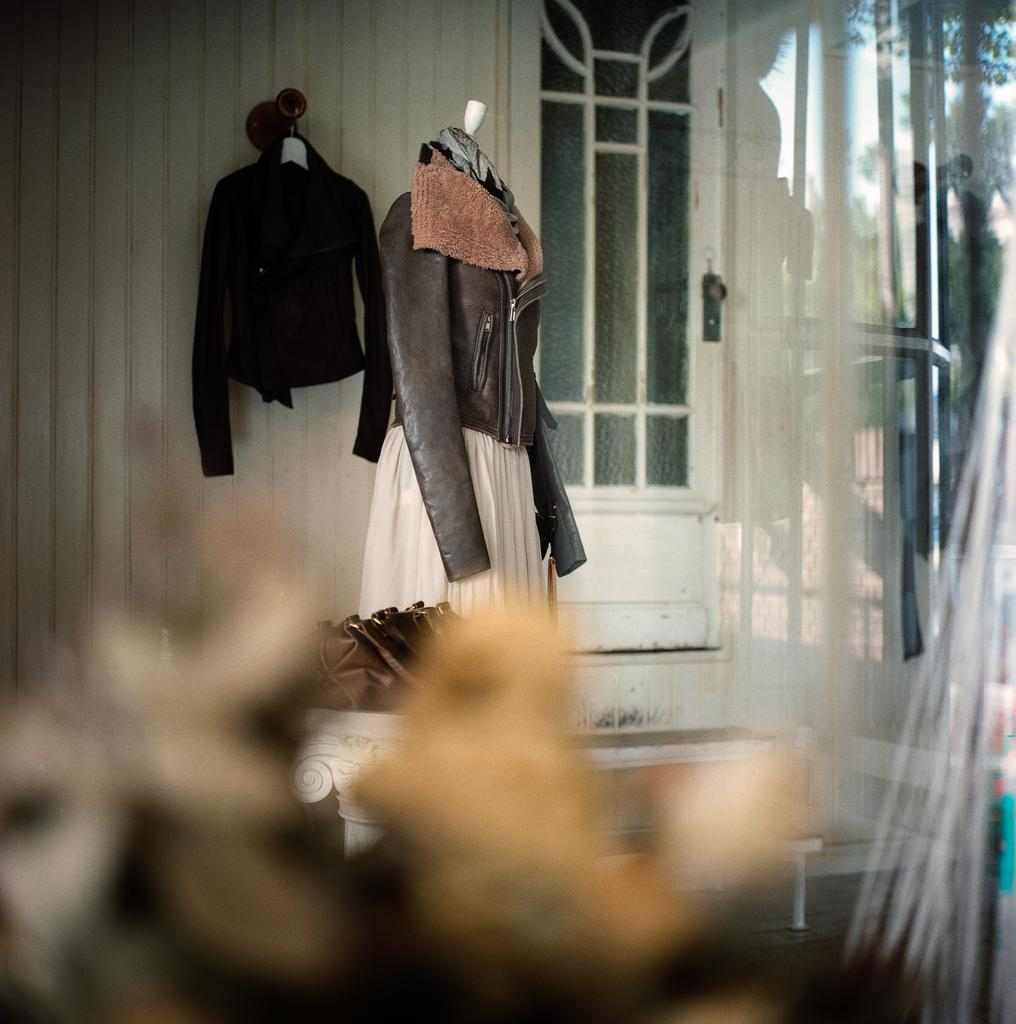What is the main subject of the image? The main subject of the image is an outfit displayed. Are there any other objects or animals in the image? Yes, there is a cat hanging on the wall and a bag in the image. What can be seen in the background of the image? There is a door visible in the background. What type of sack is being used by the creator of the outfit in the image? There is no sack or creator mentioned in the image, and therefore no such information can be provided. 